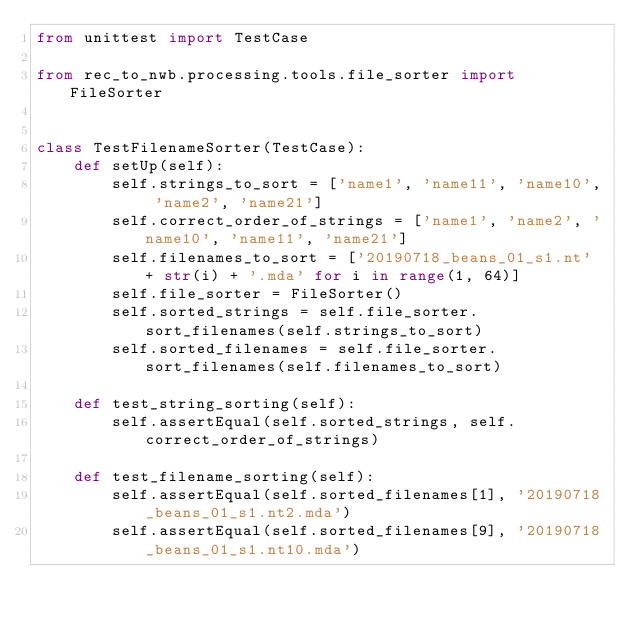Convert code to text. <code><loc_0><loc_0><loc_500><loc_500><_Python_>from unittest import TestCase

from rec_to_nwb.processing.tools.file_sorter import FileSorter


class TestFilenameSorter(TestCase):
    def setUp(self):
        self.strings_to_sort = ['name1', 'name11', 'name10', 'name2', 'name21']
        self.correct_order_of_strings = ['name1', 'name2', 'name10', 'name11', 'name21']
        self.filenames_to_sort = ['20190718_beans_01_s1.nt' + str(i) + '.mda' for i in range(1, 64)]
        self.file_sorter = FileSorter()
        self.sorted_strings = self.file_sorter.sort_filenames(self.strings_to_sort)
        self.sorted_filenames = self.file_sorter.sort_filenames(self.filenames_to_sort)

    def test_string_sorting(self):
        self.assertEqual(self.sorted_strings, self.correct_order_of_strings)

    def test_filename_sorting(self):
        self.assertEqual(self.sorted_filenames[1], '20190718_beans_01_s1.nt2.mda')
        self.assertEqual(self.sorted_filenames[9], '20190718_beans_01_s1.nt10.mda')</code> 